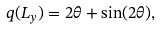Convert formula to latex. <formula><loc_0><loc_0><loc_500><loc_500>q ( L _ { y } ) = 2 \theta + \sin ( 2 \theta ) ,</formula> 